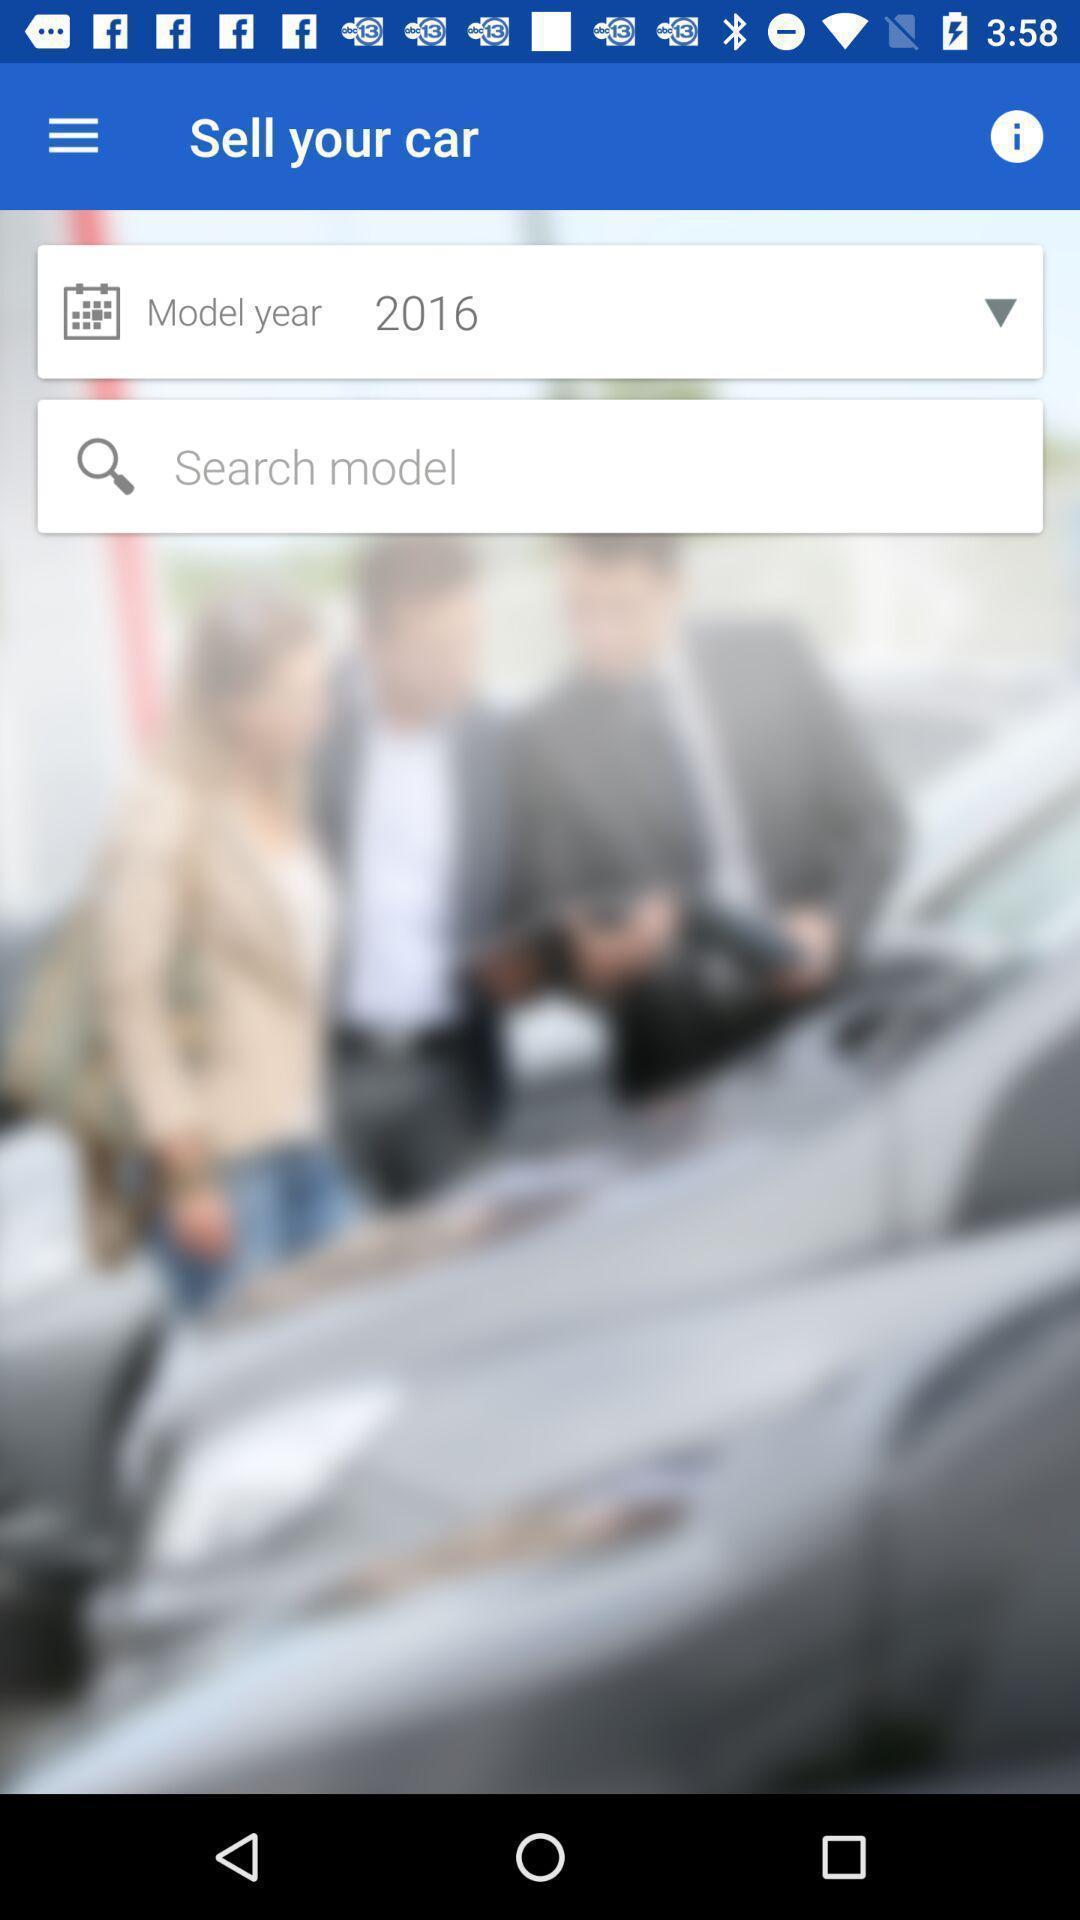Tell me about the visual elements in this screen capture. Screen showing search bar to find car models. 